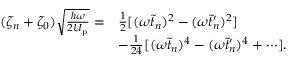<formula> <loc_0><loc_0><loc_500><loc_500>\begin{array} { r l } { ( \zeta _ { n } + \zeta _ { 0 } ) \sqrt { \frac { \hbar { \omega } } { 2 U _ { p } } } = } & { \frac { 1 } { 2 } [ ( \omega \tilde { t } _ { n } ) ^ { 2 } - ( \omega \tilde { t } _ { n } ^ { \prime } ) ^ { 2 } ] } \\ & { - \frac { 1 } { 2 4 } [ ( \omega \tilde { t } _ { n } ) ^ { 4 } - ( \omega \tilde { t } _ { n } ^ { \prime } ) ^ { 4 } + \cdots ] . } \end{array}</formula> 